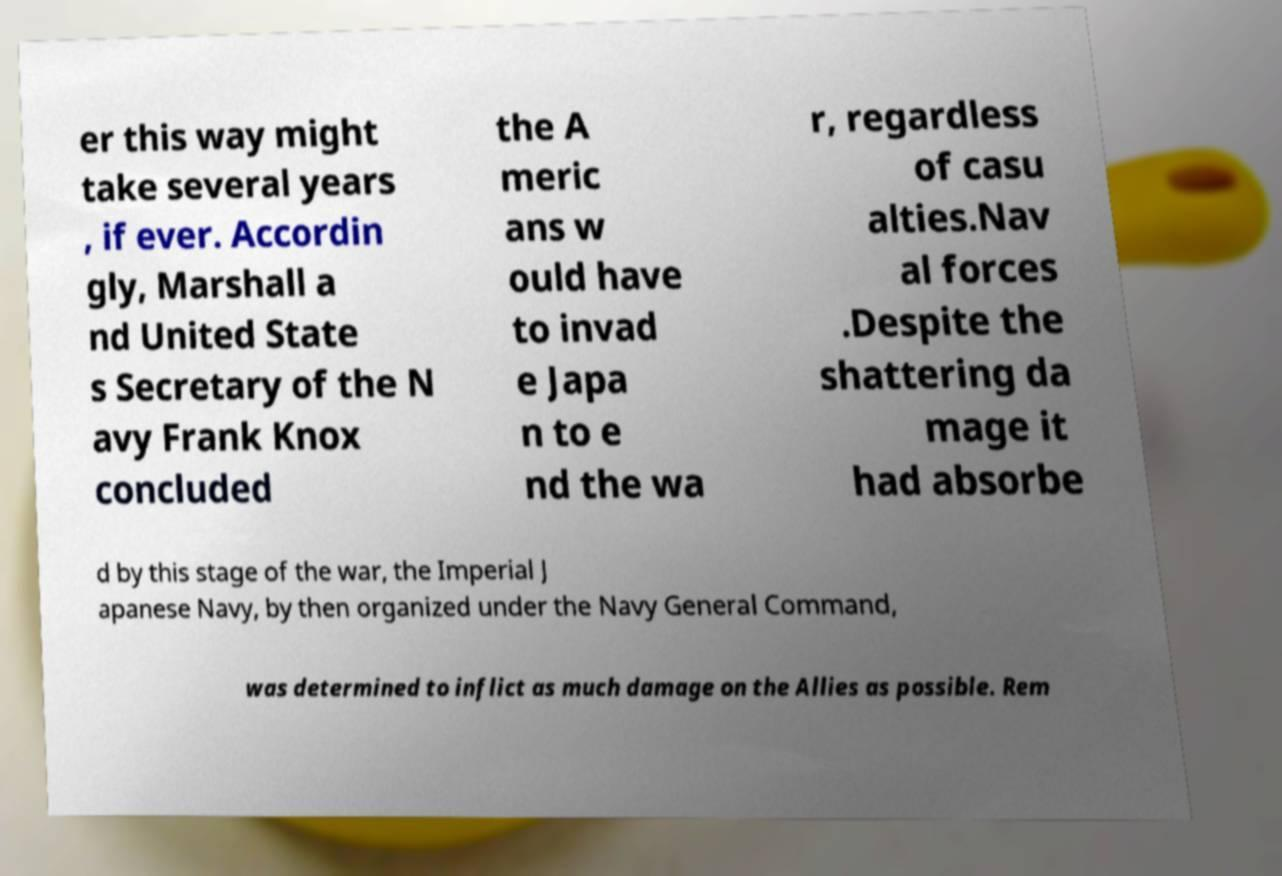Please identify and transcribe the text found in this image. er this way might take several years , if ever. Accordin gly, Marshall a nd United State s Secretary of the N avy Frank Knox concluded the A meric ans w ould have to invad e Japa n to e nd the wa r, regardless of casu alties.Nav al forces .Despite the shattering da mage it had absorbe d by this stage of the war, the Imperial J apanese Navy, by then organized under the Navy General Command, was determined to inflict as much damage on the Allies as possible. Rem 